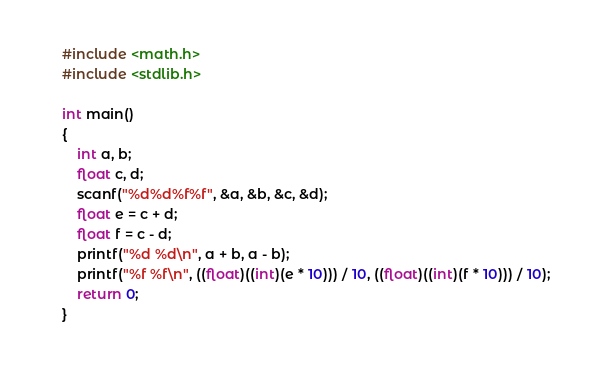Convert code to text. <code><loc_0><loc_0><loc_500><loc_500><_C++_>#include <math.h>
#include <stdlib.h>

int main()
{
    int a, b;
    float c, d;
    scanf("%d%d%f%f", &a, &b, &c, &d);
    float e = c + d;
    float f = c - d;
    printf("%d %d\n", a + b, a - b);
    printf("%f %f\n", ((float)((int)(e * 10))) / 10, ((float)((int)(f * 10))) / 10);
    return 0;
}
</code> 